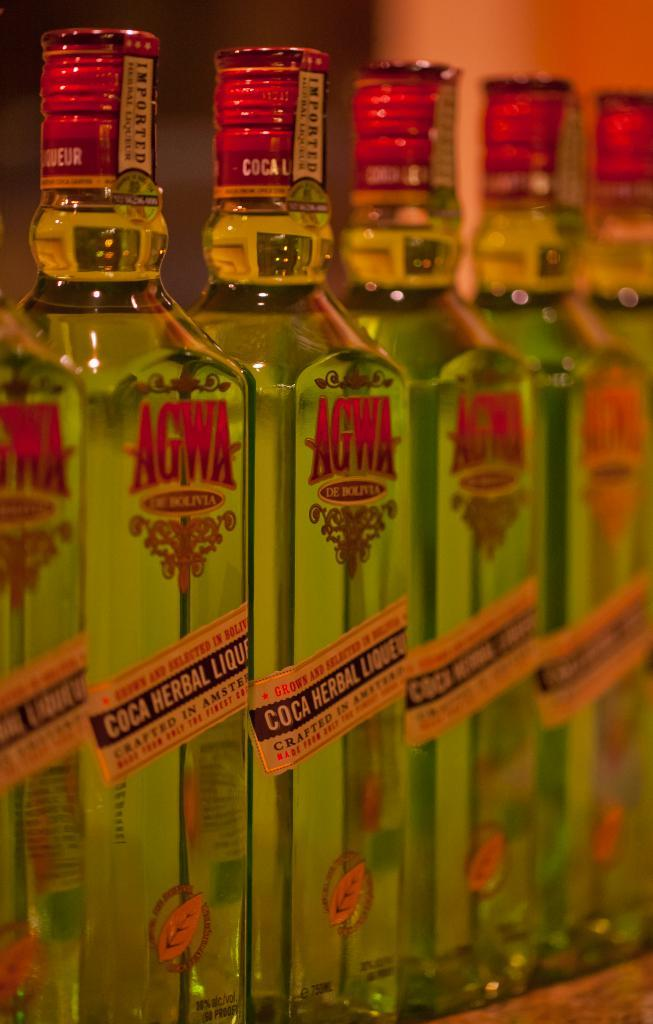<image>
Give a short and clear explanation of the subsequent image. Bottles of Agwa Coca herbal liqueur lined up in a row. 